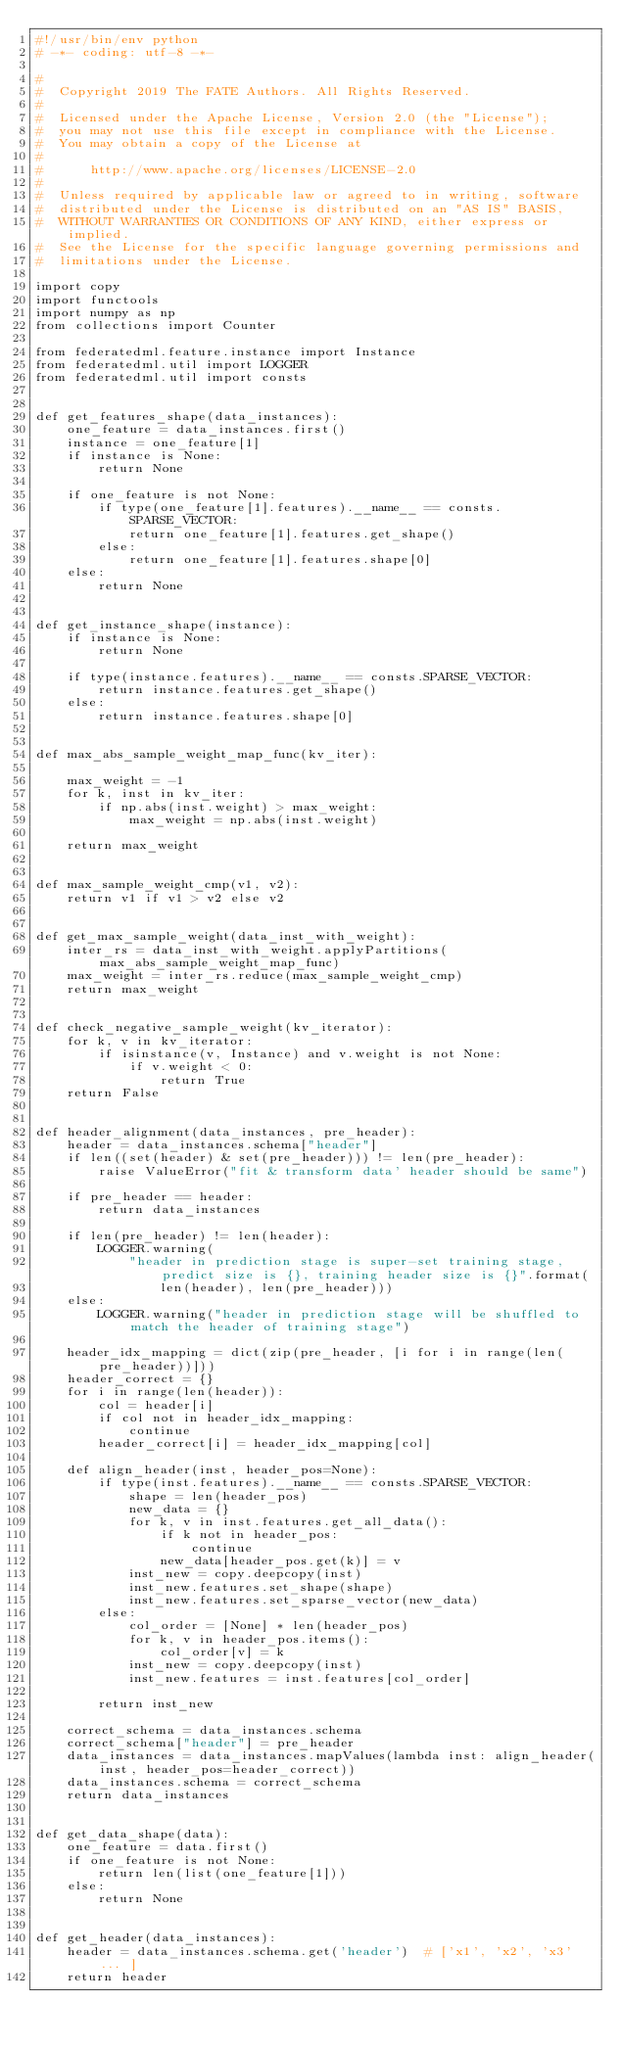<code> <loc_0><loc_0><loc_500><loc_500><_Python_>#!/usr/bin/env python
# -*- coding: utf-8 -*-

#
#  Copyright 2019 The FATE Authors. All Rights Reserved.
#
#  Licensed under the Apache License, Version 2.0 (the "License");
#  you may not use this file except in compliance with the License.
#  You may obtain a copy of the License at
#
#      http://www.apache.org/licenses/LICENSE-2.0
#
#  Unless required by applicable law or agreed to in writing, software
#  distributed under the License is distributed on an "AS IS" BASIS,
#  WITHOUT WARRANTIES OR CONDITIONS OF ANY KIND, either express or implied.
#  See the License for the specific language governing permissions and
#  limitations under the License.

import copy
import functools
import numpy as np
from collections import Counter

from federatedml.feature.instance import Instance
from federatedml.util import LOGGER
from federatedml.util import consts


def get_features_shape(data_instances):
    one_feature = data_instances.first()
    instance = one_feature[1]
    if instance is None:
        return None

    if one_feature is not None:
        if type(one_feature[1].features).__name__ == consts.SPARSE_VECTOR:
            return one_feature[1].features.get_shape()
        else:
            return one_feature[1].features.shape[0]
    else:
        return None


def get_instance_shape(instance):
    if instance is None:
        return None

    if type(instance.features).__name__ == consts.SPARSE_VECTOR:
        return instance.features.get_shape()
    else:
        return instance.features.shape[0]


def max_abs_sample_weight_map_func(kv_iter):

    max_weight = -1
    for k, inst in kv_iter:
        if np.abs(inst.weight) > max_weight:
            max_weight = np.abs(inst.weight)

    return max_weight


def max_sample_weight_cmp(v1, v2):
    return v1 if v1 > v2 else v2


def get_max_sample_weight(data_inst_with_weight):
    inter_rs = data_inst_with_weight.applyPartitions(max_abs_sample_weight_map_func)
    max_weight = inter_rs.reduce(max_sample_weight_cmp)
    return max_weight


def check_negative_sample_weight(kv_iterator):
    for k, v in kv_iterator:
        if isinstance(v, Instance) and v.weight is not None:
            if v.weight < 0:
                return True
    return False


def header_alignment(data_instances, pre_header):
    header = data_instances.schema["header"]
    if len((set(header) & set(pre_header))) != len(pre_header):
        raise ValueError("fit & transform data' header should be same")

    if pre_header == header:
        return data_instances

    if len(pre_header) != len(header):
        LOGGER.warning(
            "header in prediction stage is super-set training stage, predict size is {}, training header size is {}".format(
                len(header), len(pre_header)))
    else:
        LOGGER.warning("header in prediction stage will be shuffled to match the header of training stage")

    header_idx_mapping = dict(zip(pre_header, [i for i in range(len(pre_header))]))
    header_correct = {}
    for i in range(len(header)):
        col = header[i]
        if col not in header_idx_mapping:
            continue
        header_correct[i] = header_idx_mapping[col]

    def align_header(inst, header_pos=None):
        if type(inst.features).__name__ == consts.SPARSE_VECTOR:
            shape = len(header_pos)
            new_data = {}
            for k, v in inst.features.get_all_data():
                if k not in header_pos:
                    continue
                new_data[header_pos.get(k)] = v
            inst_new = copy.deepcopy(inst)
            inst_new.features.set_shape(shape)
            inst_new.features.set_sparse_vector(new_data)
        else:
            col_order = [None] * len(header_pos)
            for k, v in header_pos.items():
                col_order[v] = k
            inst_new = copy.deepcopy(inst)
            inst_new.features = inst.features[col_order]

        return inst_new

    correct_schema = data_instances.schema
    correct_schema["header"] = pre_header
    data_instances = data_instances.mapValues(lambda inst: align_header(inst, header_pos=header_correct))
    data_instances.schema = correct_schema
    return data_instances


def get_data_shape(data):
    one_feature = data.first()
    if one_feature is not None:
        return len(list(one_feature[1]))
    else:
        return None


def get_header(data_instances):
    header = data_instances.schema.get('header')  # ['x1', 'x2', 'x3' ... ]
    return header

</code> 